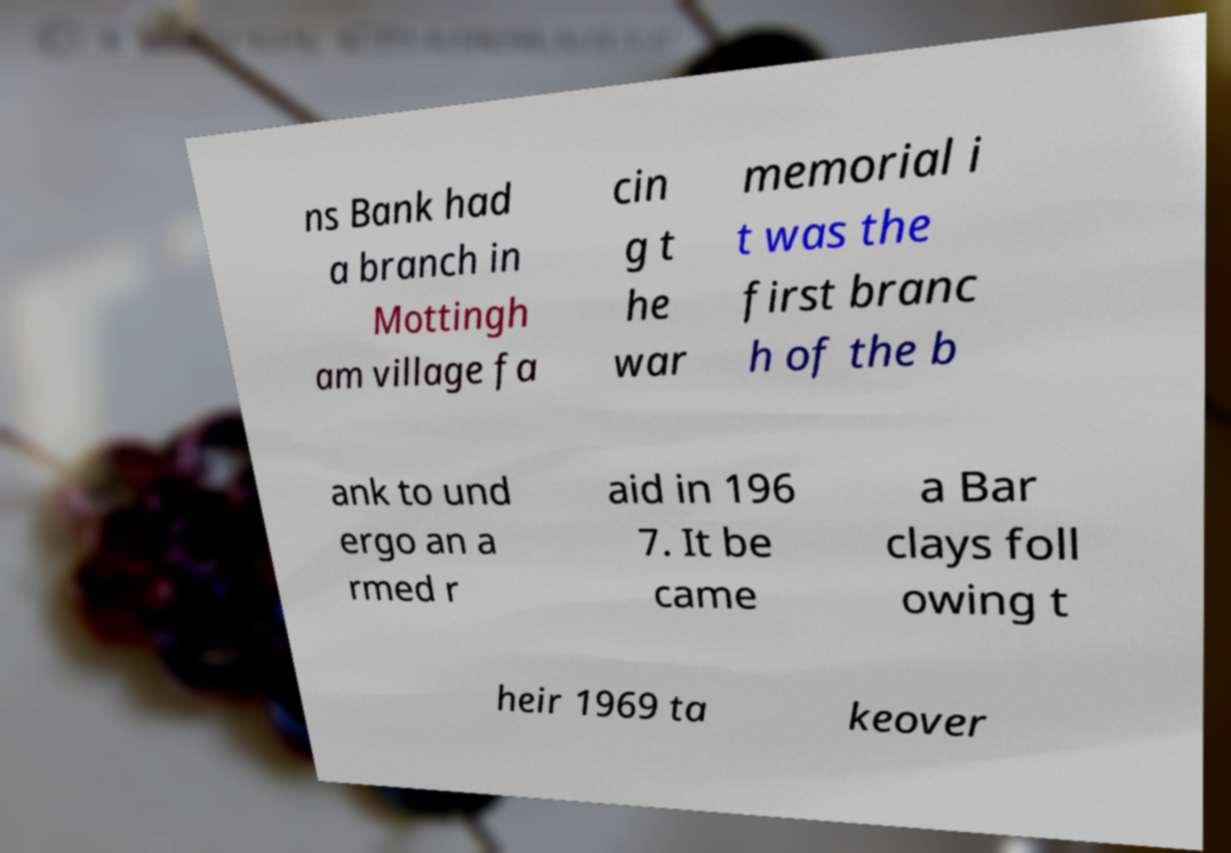I need the written content from this picture converted into text. Can you do that? ns Bank had a branch in Mottingh am village fa cin g t he war memorial i t was the first branc h of the b ank to und ergo an a rmed r aid in 196 7. It be came a Bar clays foll owing t heir 1969 ta keover 